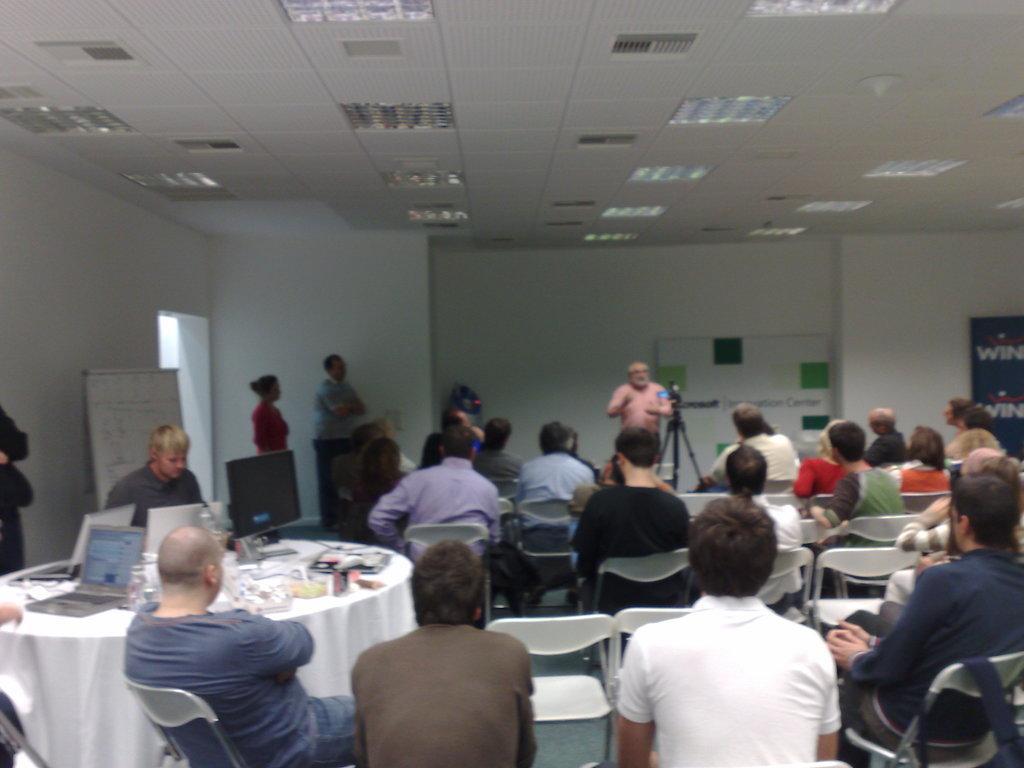Please provide a concise description of this image. In this image I can see the group of people sitting and some people are standing. To the left there is table. On the table there are some laptops. And there are boards attached to the wall. 